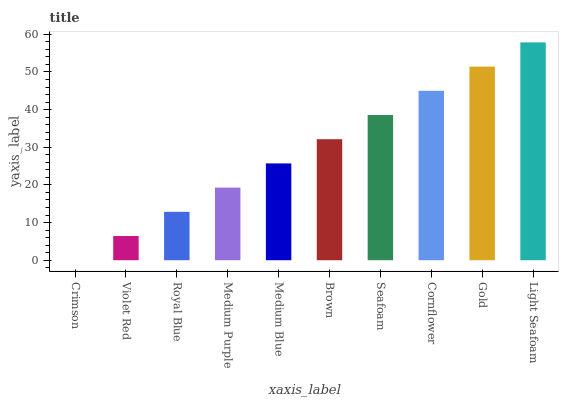Is Crimson the minimum?
Answer yes or no. Yes. Is Light Seafoam the maximum?
Answer yes or no. Yes. Is Violet Red the minimum?
Answer yes or no. No. Is Violet Red the maximum?
Answer yes or no. No. Is Violet Red greater than Crimson?
Answer yes or no. Yes. Is Crimson less than Violet Red?
Answer yes or no. Yes. Is Crimson greater than Violet Red?
Answer yes or no. No. Is Violet Red less than Crimson?
Answer yes or no. No. Is Brown the high median?
Answer yes or no. Yes. Is Medium Blue the low median?
Answer yes or no. Yes. Is Light Seafoam the high median?
Answer yes or no. No. Is Seafoam the low median?
Answer yes or no. No. 